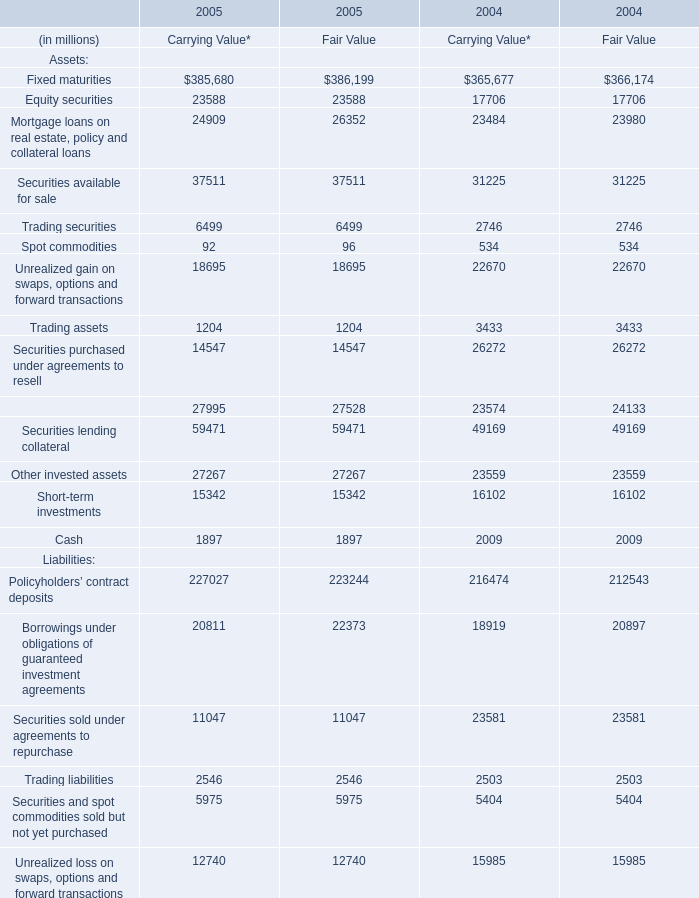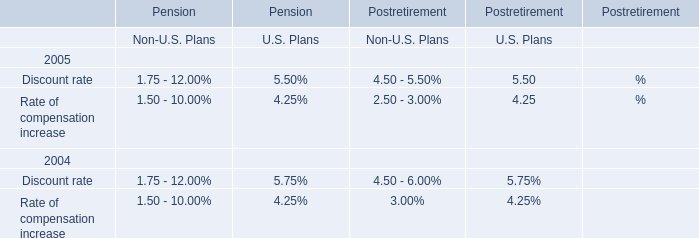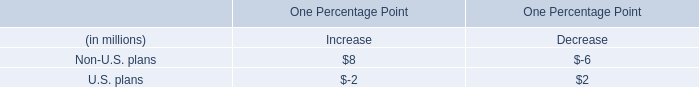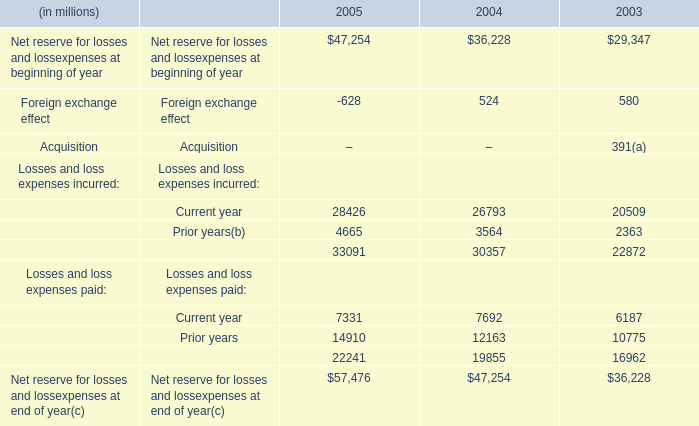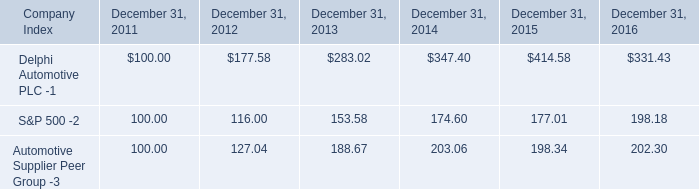what was the percentage increase in cash dividend from 2015 to 2016? 
Computations: ((0.29 - 0.25) / 0.25)
Answer: 0.16. 